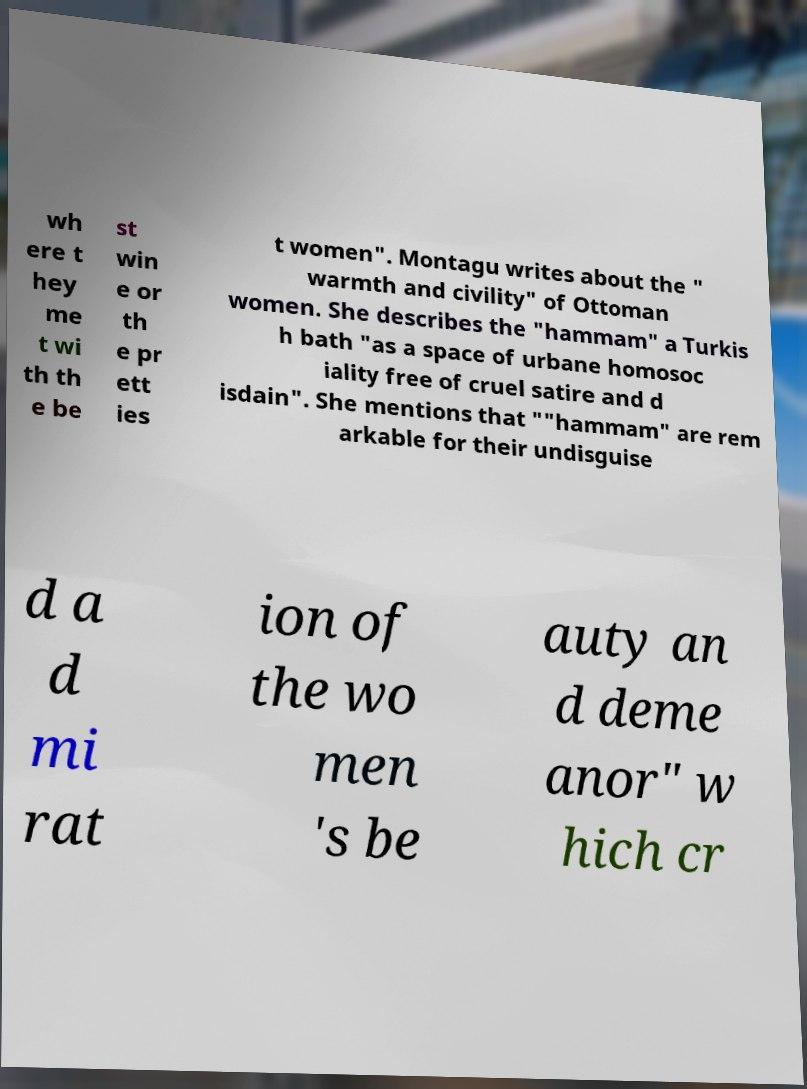For documentation purposes, I need the text within this image transcribed. Could you provide that? wh ere t hey me t wi th th e be st win e or th e pr ett ies t women". Montagu writes about the " warmth and civility" of Ottoman women. She describes the "hammam" a Turkis h bath "as a space of urbane homosoc iality free of cruel satire and d isdain". She mentions that ""hammam" are rem arkable for their undisguise d a d mi rat ion of the wo men 's be auty an d deme anor" w hich cr 